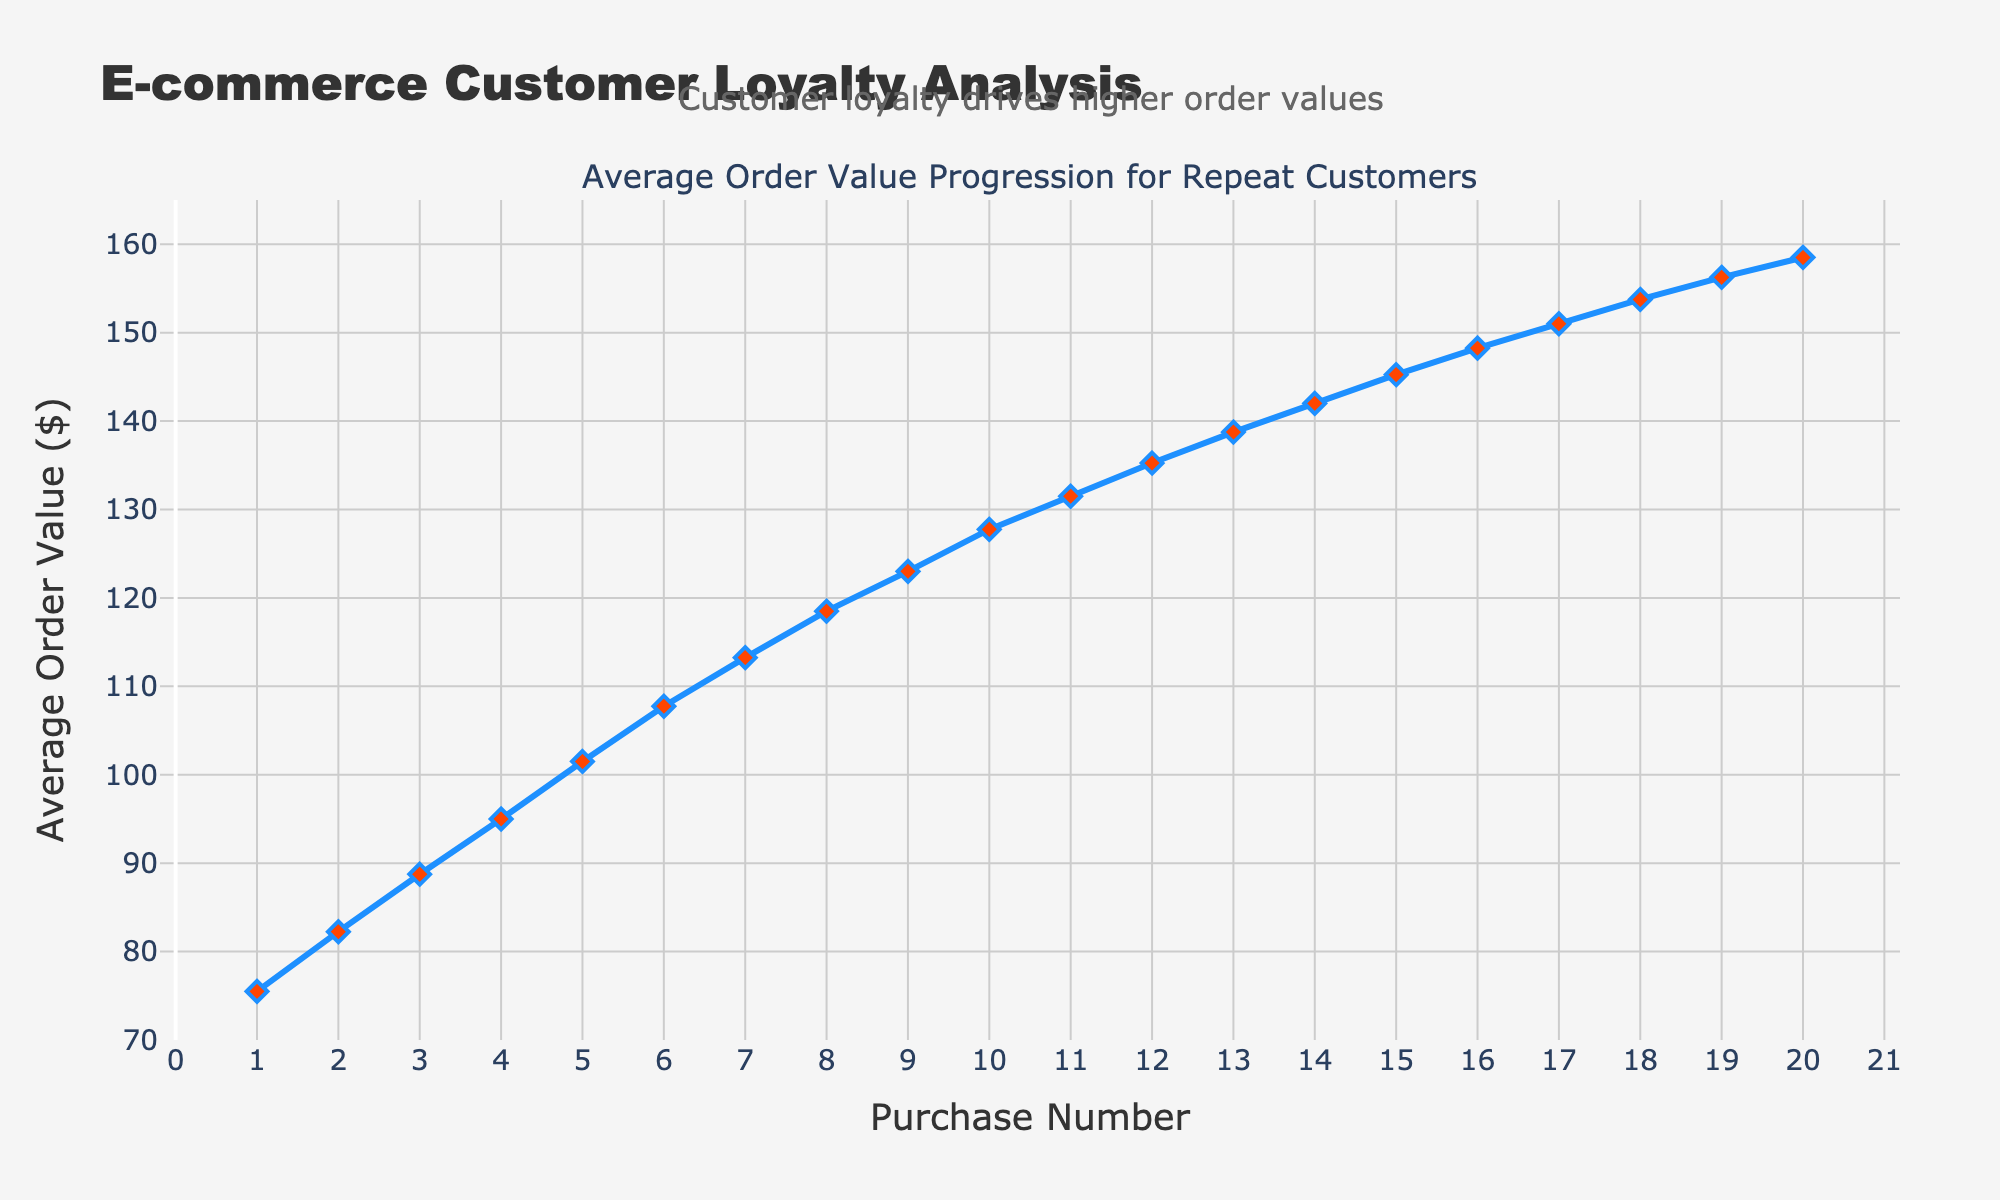What's the average order value by the 5th purchase? To find the average order value by the 5th purchase, look at the y-axis value that corresponds with the x-axis value of 5. The value is 101.50.
Answer: 101.50 How much does the average order value increase from the 2nd to the 3rd purchase? Find the average order value for the 2nd purchase (82.25) and the 3rd purchase (88.75). Subtract the value for the 2nd purchase from the value for the 3rd purchase: 88.75 - 82.25 = 6.50.
Answer: 6.50 At which purchase number does the average order value exceed $100? Look at when the y-axis value crosses the $100 mark. This happens around the 5th purchase, as the value is 101.50.
Answer: 5th What is the difference in average order value between the 10th and the 20th purchase? Find the average order value for the 10th purchase (127.75) and the 20th purchase (158.50). Subtract the 10th purchase value from the 20th purchase value: 158.50 - 127.75 = 30.75.
Answer: 30.75 Are there any purchases where the average value decreases from the previous purchase? Examine the line chart for any downward trend. The graph shows a steady (increasing) upward trend with no decreases.
Answer: No How much does the average order value increase from the 1st to the 10th purchase? Find the average order value for the 1st purchase (75.50) and the 10th purchase (127.75). Subtract the value for the 1st purchase from the value for the 10th purchase: 127.75 - 75.50 = 52.25.
Answer: 52.25 Which purchase number shows the highest average order value? Look for the highest y-axis value on the chart. The peak occurs at the 20th purchase with an average order value of 158.50.
Answer: 20th What is the average of the average order values for the first 4 purchases? Find the values for the first 4 purchases: 75.50, 82.25, 88.75, and 95.00. Add them together and divide by 4: (75.50 + 82.25 + 88.75 + 95.00)/4 = 341.50/4 = 85.375.
Answer: 85.375 How does the color of the markers change based on the data? The markers on the line are colored red and their outline is blue, making them easily distinguishable.
Answer: Red with a blue outline Does the annotation provide any insight into the trend observed? Yes, the annotation "Customer loyalty drives higher order values" suggests that the increased average order value trend is due to customer loyalty.
Answer: Yes 